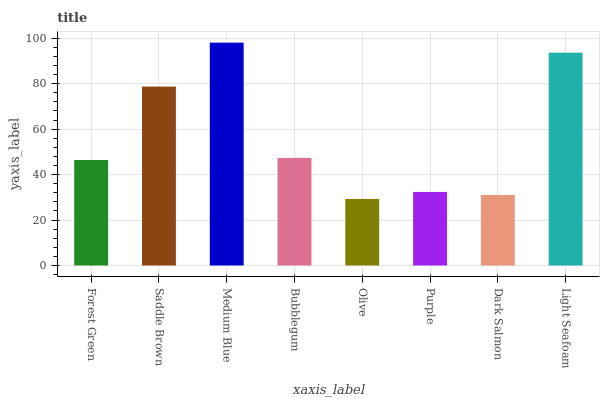Is Olive the minimum?
Answer yes or no. Yes. Is Medium Blue the maximum?
Answer yes or no. Yes. Is Saddle Brown the minimum?
Answer yes or no. No. Is Saddle Brown the maximum?
Answer yes or no. No. Is Saddle Brown greater than Forest Green?
Answer yes or no. Yes. Is Forest Green less than Saddle Brown?
Answer yes or no. Yes. Is Forest Green greater than Saddle Brown?
Answer yes or no. No. Is Saddle Brown less than Forest Green?
Answer yes or no. No. Is Bubblegum the high median?
Answer yes or no. Yes. Is Forest Green the low median?
Answer yes or no. Yes. Is Light Seafoam the high median?
Answer yes or no. No. Is Dark Salmon the low median?
Answer yes or no. No. 